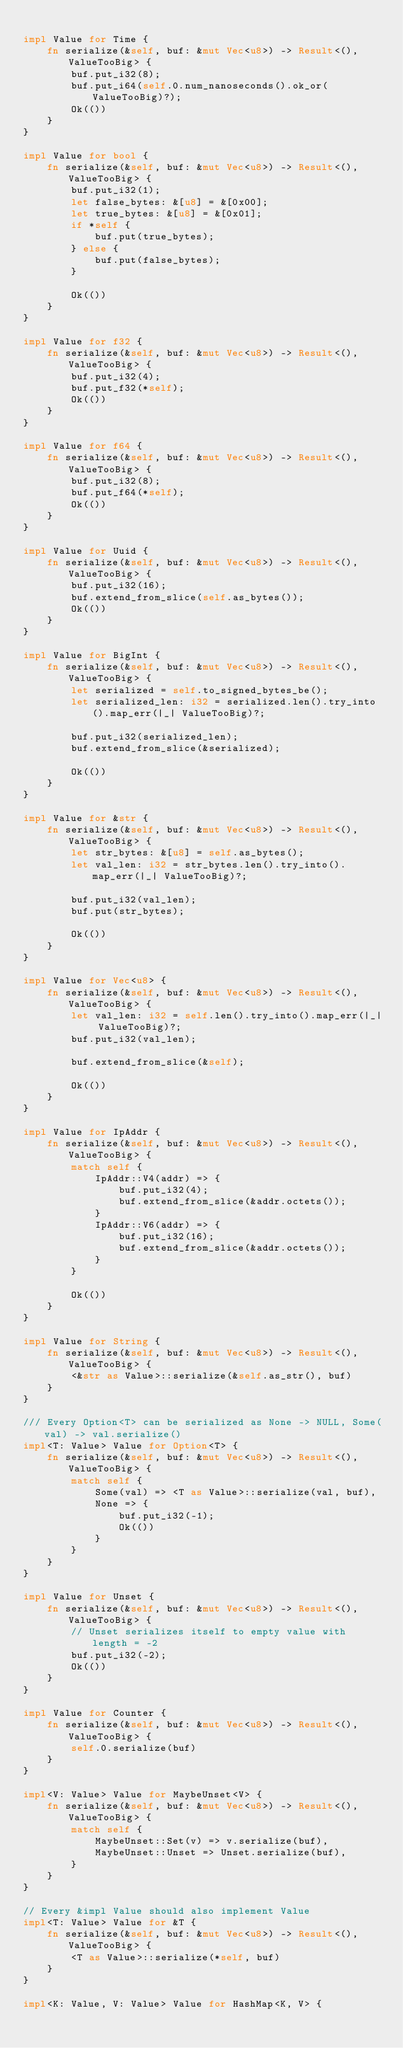<code> <loc_0><loc_0><loc_500><loc_500><_Rust_>
impl Value for Time {
    fn serialize(&self, buf: &mut Vec<u8>) -> Result<(), ValueTooBig> {
        buf.put_i32(8);
        buf.put_i64(self.0.num_nanoseconds().ok_or(ValueTooBig)?);
        Ok(())
    }
}

impl Value for bool {
    fn serialize(&self, buf: &mut Vec<u8>) -> Result<(), ValueTooBig> {
        buf.put_i32(1);
        let false_bytes: &[u8] = &[0x00];
        let true_bytes: &[u8] = &[0x01];
        if *self {
            buf.put(true_bytes);
        } else {
            buf.put(false_bytes);
        }

        Ok(())
    }
}

impl Value for f32 {
    fn serialize(&self, buf: &mut Vec<u8>) -> Result<(), ValueTooBig> {
        buf.put_i32(4);
        buf.put_f32(*self);
        Ok(())
    }
}

impl Value for f64 {
    fn serialize(&self, buf: &mut Vec<u8>) -> Result<(), ValueTooBig> {
        buf.put_i32(8);
        buf.put_f64(*self);
        Ok(())
    }
}

impl Value for Uuid {
    fn serialize(&self, buf: &mut Vec<u8>) -> Result<(), ValueTooBig> {
        buf.put_i32(16);
        buf.extend_from_slice(self.as_bytes());
        Ok(())
    }
}

impl Value for BigInt {
    fn serialize(&self, buf: &mut Vec<u8>) -> Result<(), ValueTooBig> {
        let serialized = self.to_signed_bytes_be();
        let serialized_len: i32 = serialized.len().try_into().map_err(|_| ValueTooBig)?;

        buf.put_i32(serialized_len);
        buf.extend_from_slice(&serialized);

        Ok(())
    }
}

impl Value for &str {
    fn serialize(&self, buf: &mut Vec<u8>) -> Result<(), ValueTooBig> {
        let str_bytes: &[u8] = self.as_bytes();
        let val_len: i32 = str_bytes.len().try_into().map_err(|_| ValueTooBig)?;

        buf.put_i32(val_len);
        buf.put(str_bytes);

        Ok(())
    }
}

impl Value for Vec<u8> {
    fn serialize(&self, buf: &mut Vec<u8>) -> Result<(), ValueTooBig> {
        let val_len: i32 = self.len().try_into().map_err(|_| ValueTooBig)?;
        buf.put_i32(val_len);

        buf.extend_from_slice(&self);

        Ok(())
    }
}

impl Value for IpAddr {
    fn serialize(&self, buf: &mut Vec<u8>) -> Result<(), ValueTooBig> {
        match self {
            IpAddr::V4(addr) => {
                buf.put_i32(4);
                buf.extend_from_slice(&addr.octets());
            }
            IpAddr::V6(addr) => {
                buf.put_i32(16);
                buf.extend_from_slice(&addr.octets());
            }
        }

        Ok(())
    }
}

impl Value for String {
    fn serialize(&self, buf: &mut Vec<u8>) -> Result<(), ValueTooBig> {
        <&str as Value>::serialize(&self.as_str(), buf)
    }
}

/// Every Option<T> can be serialized as None -> NULL, Some(val) -> val.serialize()
impl<T: Value> Value for Option<T> {
    fn serialize(&self, buf: &mut Vec<u8>) -> Result<(), ValueTooBig> {
        match self {
            Some(val) => <T as Value>::serialize(val, buf),
            None => {
                buf.put_i32(-1);
                Ok(())
            }
        }
    }
}

impl Value for Unset {
    fn serialize(&self, buf: &mut Vec<u8>) -> Result<(), ValueTooBig> {
        // Unset serializes itself to empty value with length = -2
        buf.put_i32(-2);
        Ok(())
    }
}

impl Value for Counter {
    fn serialize(&self, buf: &mut Vec<u8>) -> Result<(), ValueTooBig> {
        self.0.serialize(buf)
    }
}

impl<V: Value> Value for MaybeUnset<V> {
    fn serialize(&self, buf: &mut Vec<u8>) -> Result<(), ValueTooBig> {
        match self {
            MaybeUnset::Set(v) => v.serialize(buf),
            MaybeUnset::Unset => Unset.serialize(buf),
        }
    }
}

// Every &impl Value should also implement Value
impl<T: Value> Value for &T {
    fn serialize(&self, buf: &mut Vec<u8>) -> Result<(), ValueTooBig> {
        <T as Value>::serialize(*self, buf)
    }
}

impl<K: Value, V: Value> Value for HashMap<K, V> {</code> 